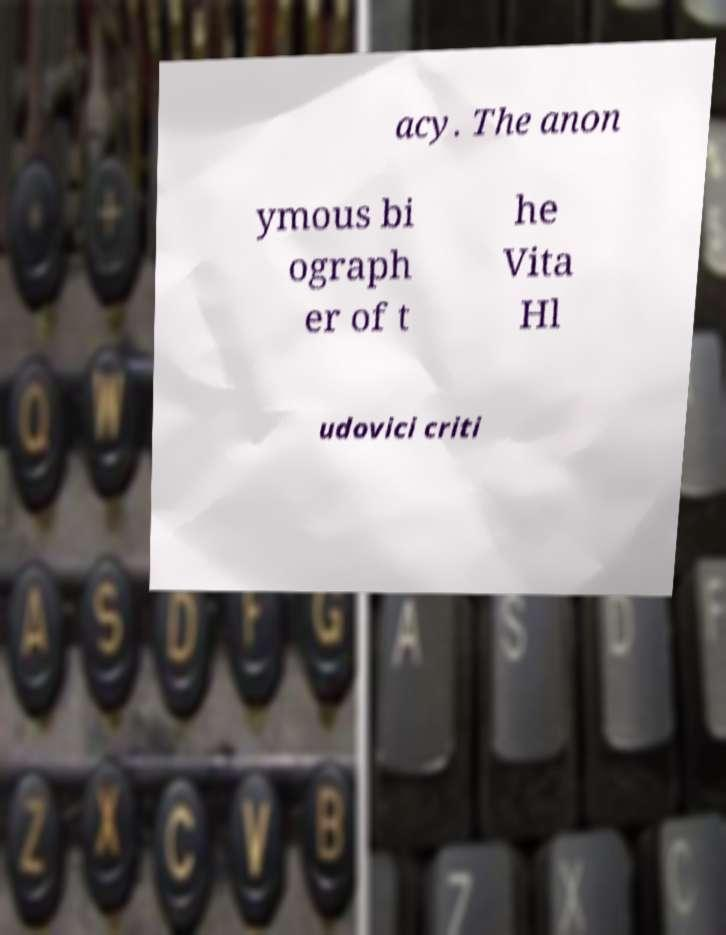Please identify and transcribe the text found in this image. acy. The anon ymous bi ograph er of t he Vita Hl udovici criti 